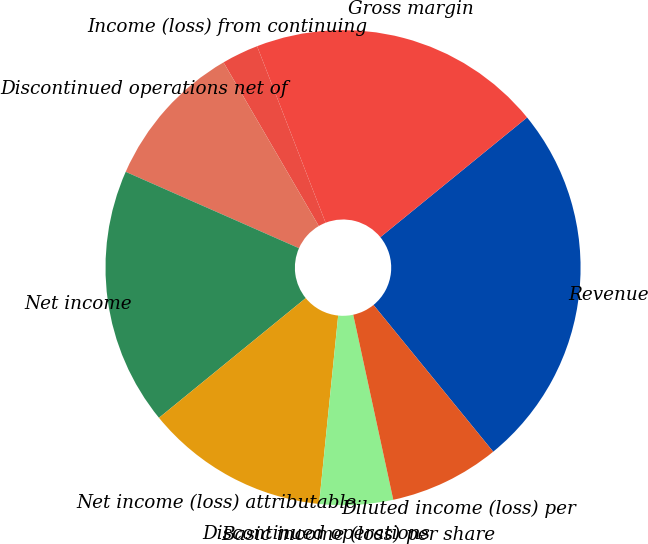Convert chart to OTSL. <chart><loc_0><loc_0><loc_500><loc_500><pie_chart><fcel>Revenue<fcel>Gross margin<fcel>Income (loss) from continuing<fcel>Discontinued operations net of<fcel>Net income<fcel>Net income (loss) attributable<fcel>Discontinued operations<fcel>Basic income (loss) per share<fcel>Diluted income (loss) per<nl><fcel>25.0%<fcel>20.0%<fcel>2.5%<fcel>10.0%<fcel>17.5%<fcel>12.5%<fcel>0.0%<fcel>5.0%<fcel>7.5%<nl></chart> 